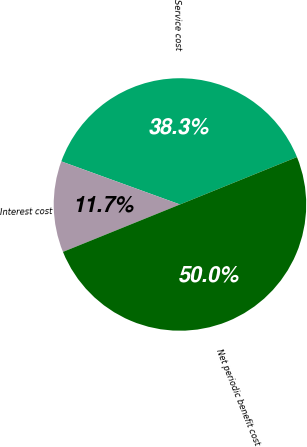<chart> <loc_0><loc_0><loc_500><loc_500><pie_chart><fcel>Service cost<fcel>Interest cost<fcel>Net periodic benefit cost<nl><fcel>38.33%<fcel>11.67%<fcel>50.0%<nl></chart> 